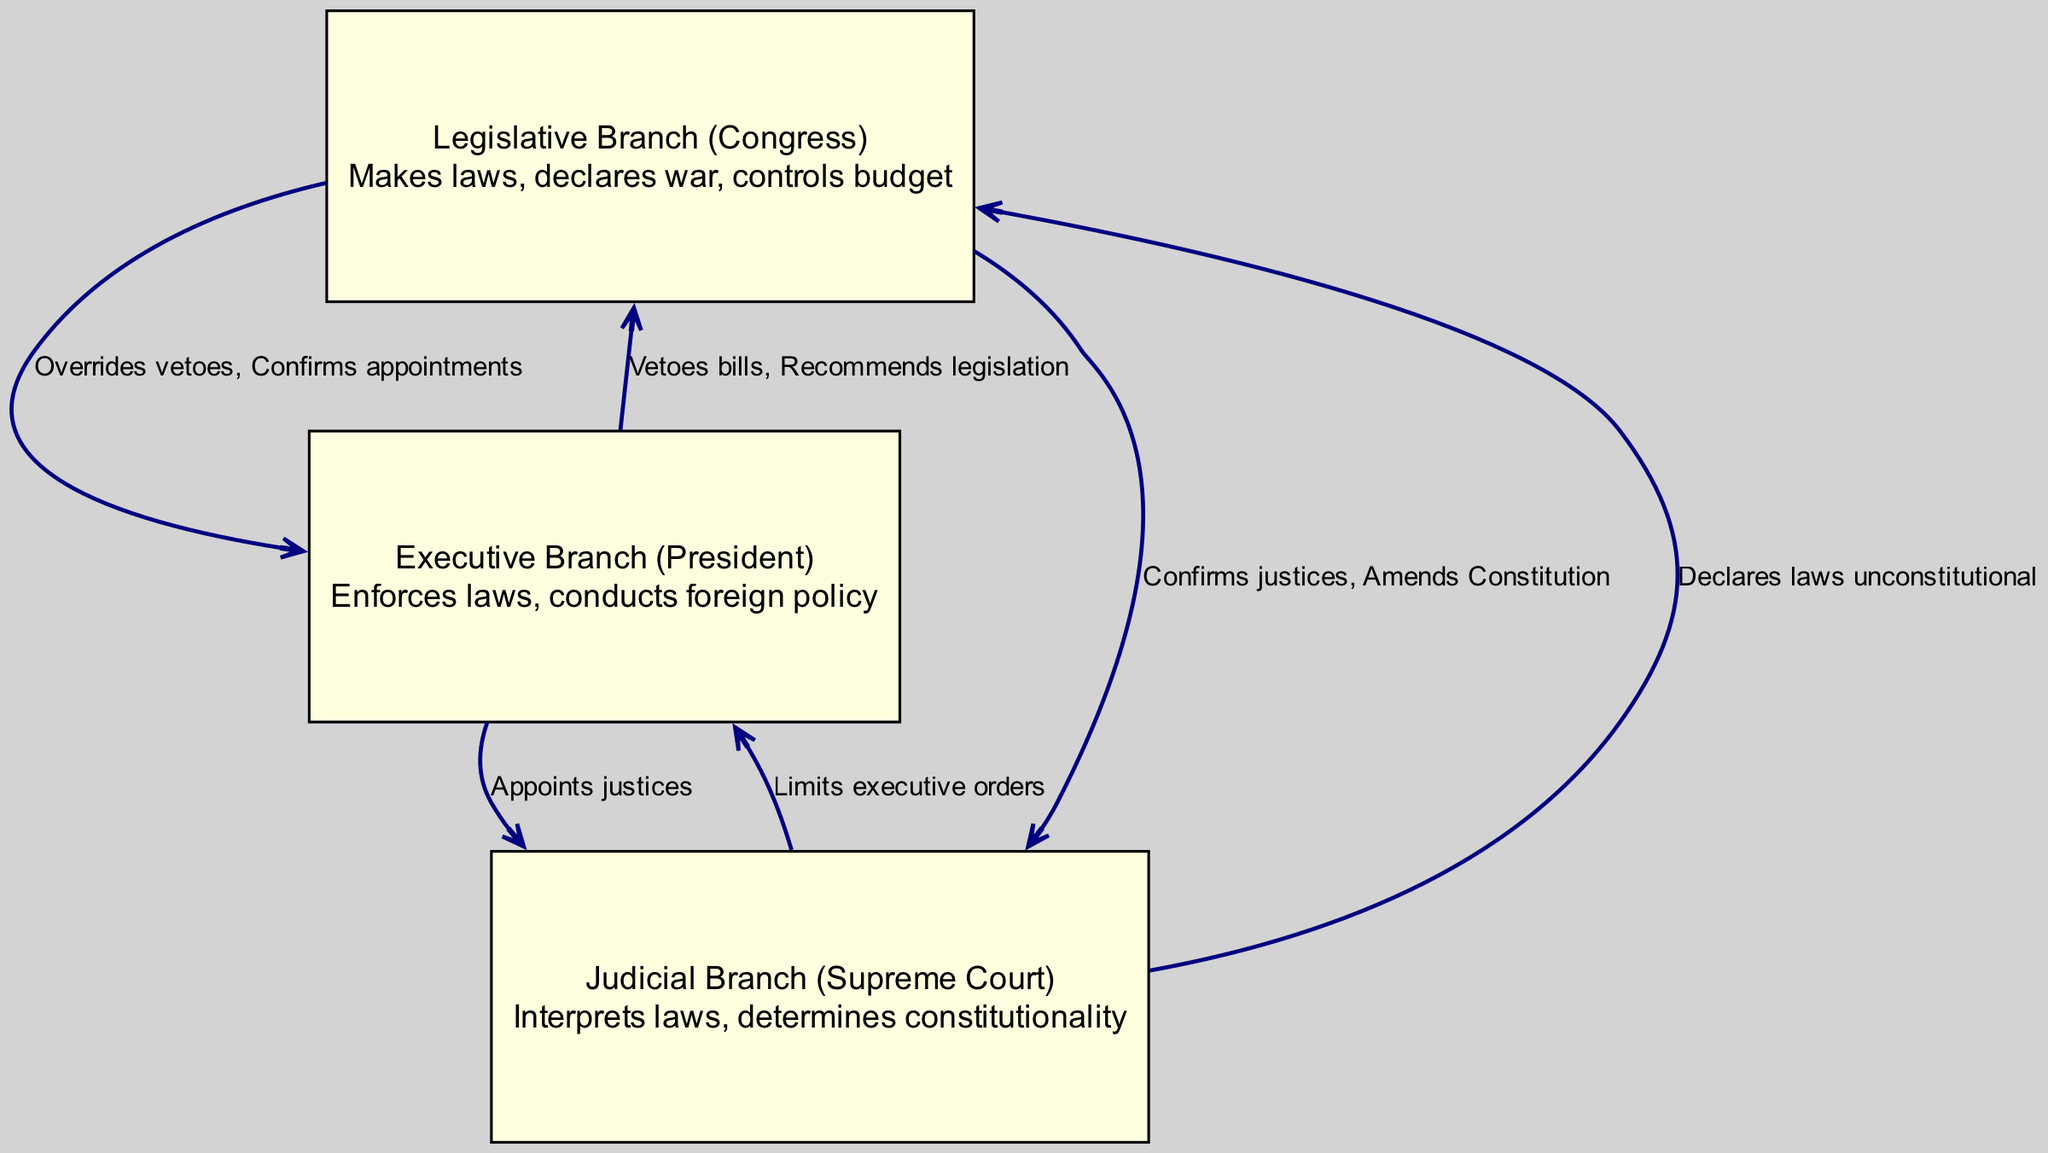What is the primary function of the Legislative Branch? The diagram shows that the Legislative Branch (Congress) is responsible for making laws, declaring war, and controlling the budget. This information is contained in the node description for the Legislative Branch.
Answer: Makes laws, declares war, controls budget How many branches of government are represented in the diagram? The diagram contains three nodes representing the three branches: Legislative, Executive, and Judicial. The count of these nodes gives us the total number of branches.
Answer: 3 What action can the Executive Branch take against a bill passed by Congress? According to the diagram, one of the relationships shows that the Executive Branch can veto bills, which is a direct action it can take against legislation passed by Congress.
Answer: Vetoes bills Which branch limits the power of the Executive Branch? The diagram indicates that the Judicial Branch can limit executive orders, illustrating a check on the Executive’s power.
Answer: Judicial Branch Which two branches can confirm justices? The diagram shows that both the Legislative Branch and the Executive Branch are involved in confirming justices, as indicated in the relationships with the Judicial Branch.
Answer: Legislative Branch, Executive Branch What role does the Judicial Branch play in relation to laws? The diagram illustrates that the Judicial Branch interprets laws and can declare laws unconstitutional, showcasing its role in the legal system.
Answer: Interprets laws, declares laws unconstitutional What action does the Legislative Branch have over the Executive Branch? The diagram includes an edge showing that the Legislative Branch can override vetoes and confirm appointments of the Executive Branch, detailing its checking ability.
Answer: Overrides vetoes, Confirms appointments How does the Executive Branch influence legislation? The diagram indicates that the Executive Branch can recommend legislation, demonstrating how it can influence the legislative process in Congress.
Answer: Recommends legislation What is the relationship between the Judicial Branch and the Legislative Branch? The diagram shows that the Judicial Branch has the power to declare laws unconstitutional, which indicates a direct relationship and check on the Legislative Branch's authority.
Answer: Declares laws unconstitutional Which branch has the authority to conduct foreign policy? The diagram states that the Executive Branch, led by the President, conducts foreign policy, indicating its primary function in this area.
Answer: Executive Branch 